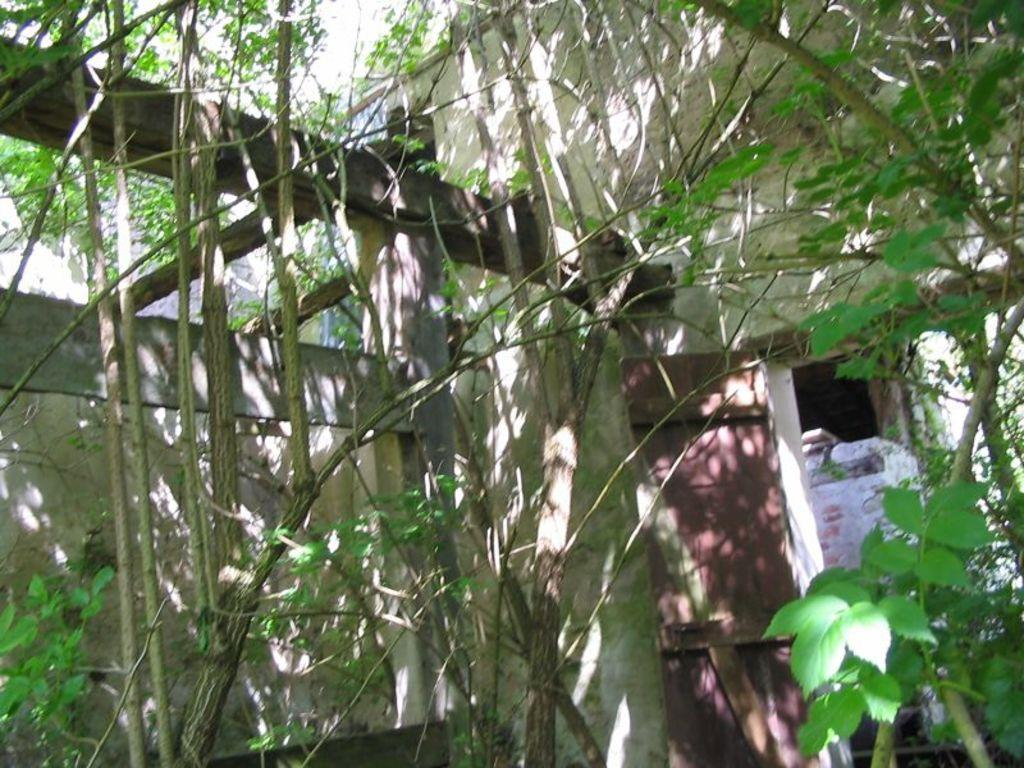What type of living organisms can be seen in the image? Plants can be seen in the image. What architectural feature is present in the image? There is a door in the image. What is the background of the image made of? There is a wall in the image. What type of pin can be seen holding the plants in the image? There is no pin present in the image; the plants are not attached to anything. 